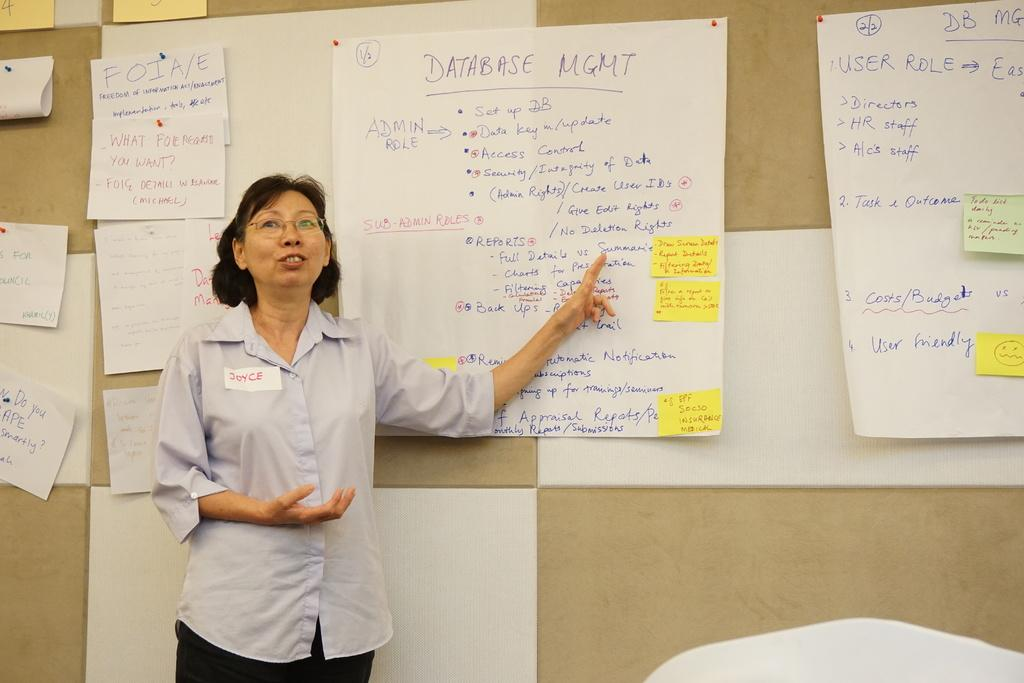Who is present in the image? There is a woman in the image. What is the woman doing in the image? The woman is standing. What type of clothing is the woman wearing? The woman is wearing a shirt and pants. What can be seen on the wall in the background? There are papers and charts attached to the wall in the background. What type of worm can be seen crawling on the woman's shirt in the image? There is no worm present on the woman's shirt in the image. What is the woman using to fill the basin in the image? There is no basin present in the image. 